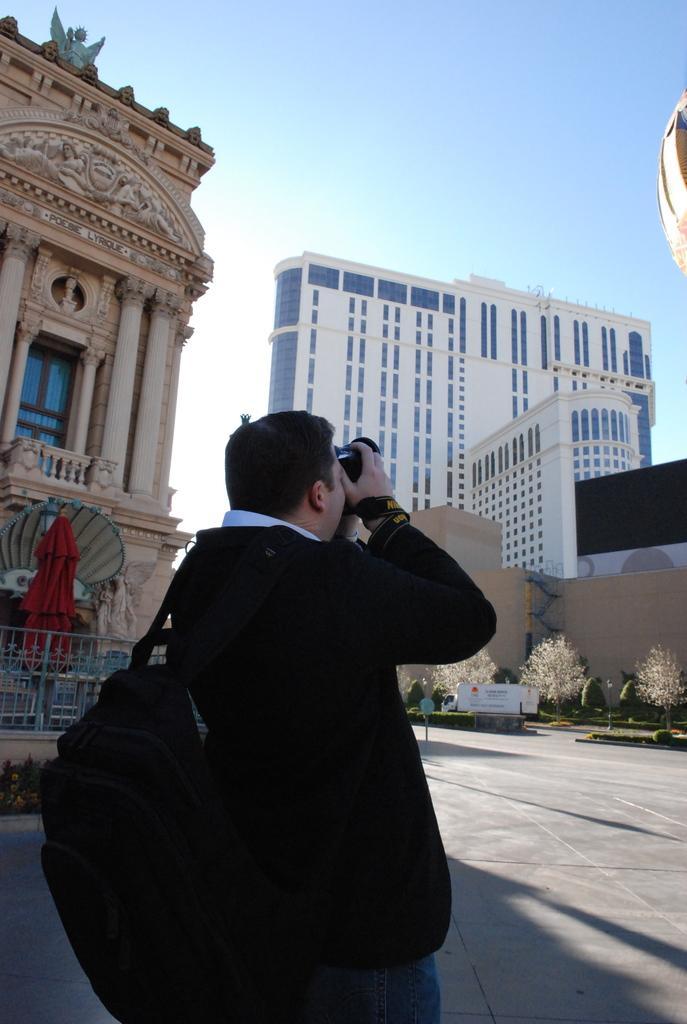How would you summarize this image in a sentence or two? There is a man holding a camera and wearing a bag in the foreground area of the image, there are buildings, it seems like an umbrella, plants and the sky in the background. 